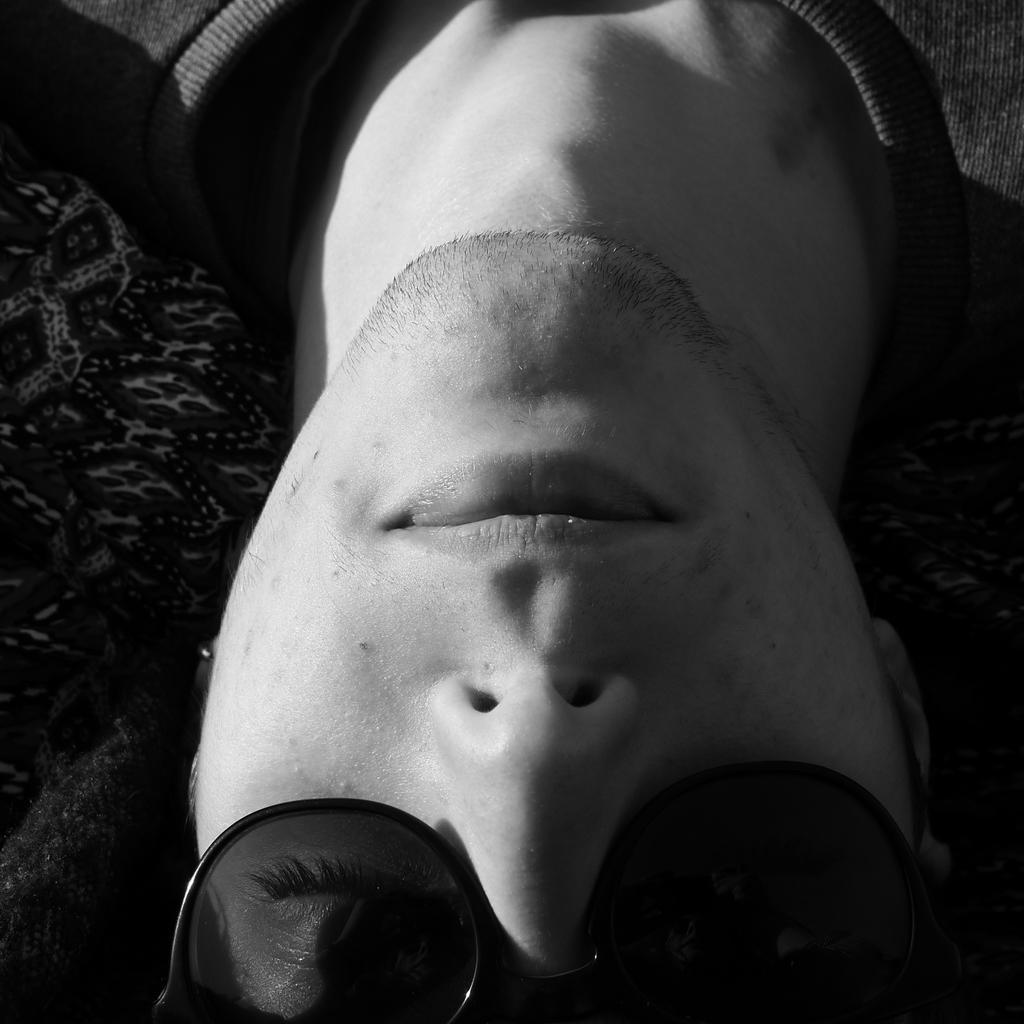Describe this image in one or two sentences. In this image I can see a person head and neck and person wearing spectacle. 